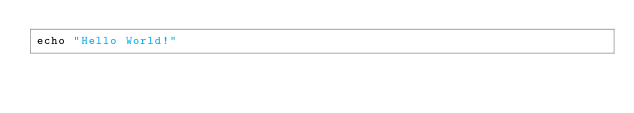Convert code to text. <code><loc_0><loc_0><loc_500><loc_500><_Nim_>echo "Hello World!"
</code> 